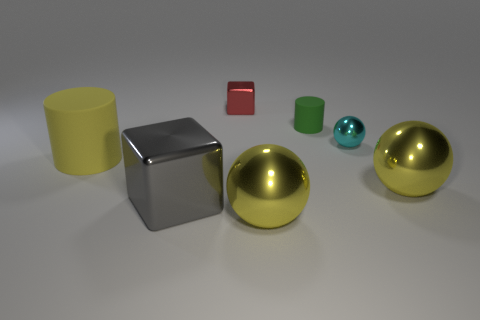Can you describe the texture of the objects in the image? Certainly! The image shows a variety of objects with different textures. The large yellow cylinder and the smaller green one have a smooth but matte finish, suggesting they could be made of a painted material like plastic. The red block appears to have a reflective, somewhat glossy texture, indicative of a polished surface, whereas the metallic block and the spheres have a highly reflective surface, demonstrating a smooth metal finish. 